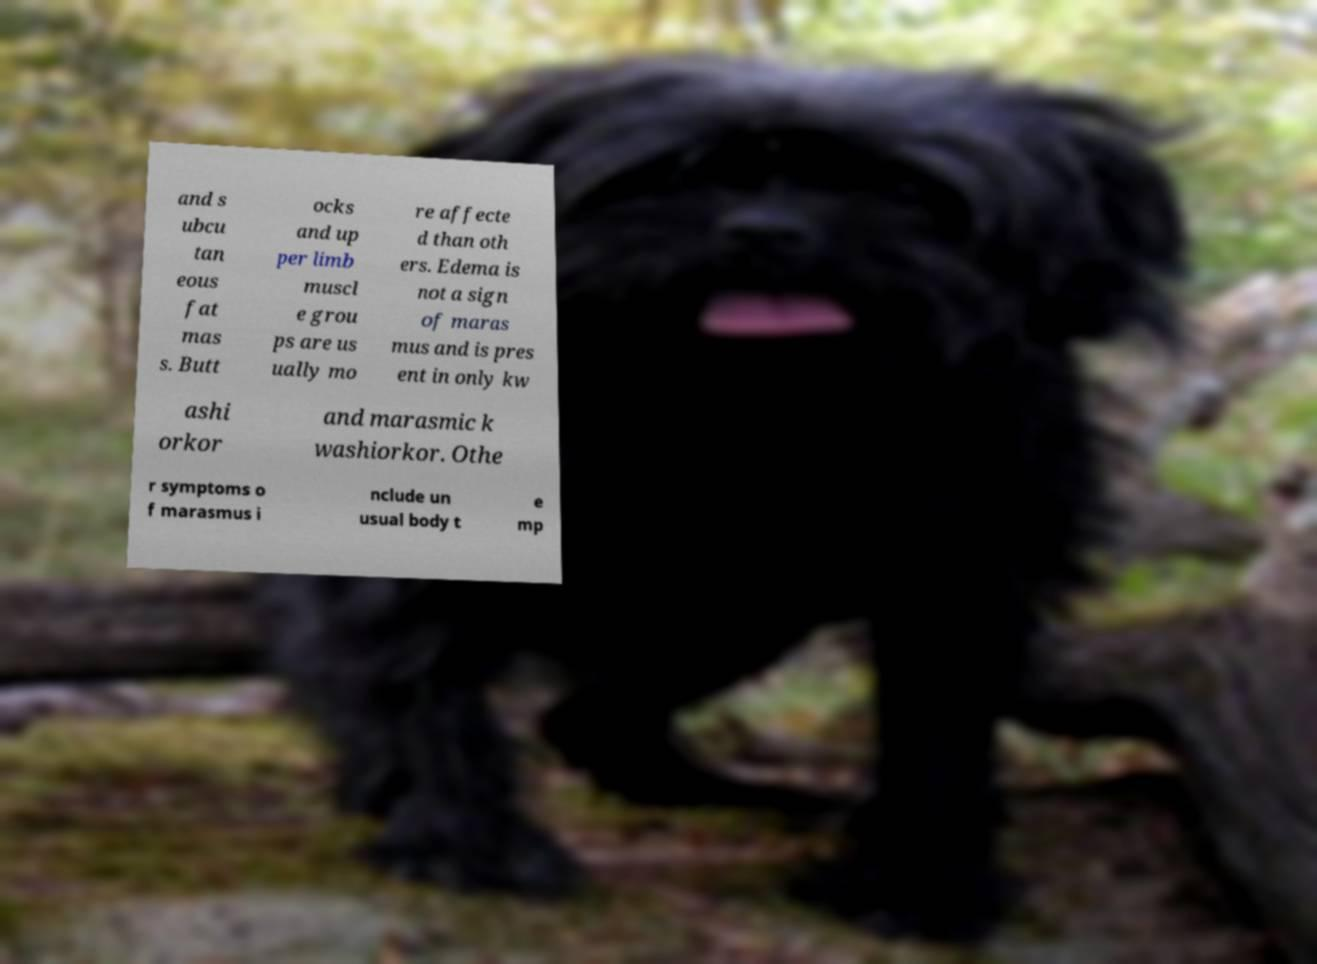Could you extract and type out the text from this image? and s ubcu tan eous fat mas s. Butt ocks and up per limb muscl e grou ps are us ually mo re affecte d than oth ers. Edema is not a sign of maras mus and is pres ent in only kw ashi orkor and marasmic k washiorkor. Othe r symptoms o f marasmus i nclude un usual body t e mp 